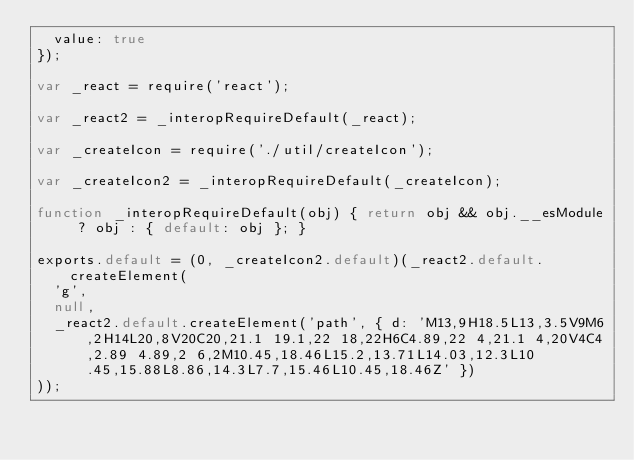Convert code to text. <code><loc_0><loc_0><loc_500><loc_500><_JavaScript_>  value: true
});

var _react = require('react');

var _react2 = _interopRequireDefault(_react);

var _createIcon = require('./util/createIcon');

var _createIcon2 = _interopRequireDefault(_createIcon);

function _interopRequireDefault(obj) { return obj && obj.__esModule ? obj : { default: obj }; }

exports.default = (0, _createIcon2.default)(_react2.default.createElement(
  'g',
  null,
  _react2.default.createElement('path', { d: 'M13,9H18.5L13,3.5V9M6,2H14L20,8V20C20,21.1 19.1,22 18,22H6C4.89,22 4,21.1 4,20V4C4,2.89 4.89,2 6,2M10.45,18.46L15.2,13.71L14.03,12.3L10.45,15.88L8.86,14.3L7.7,15.46L10.45,18.46Z' })
));</code> 